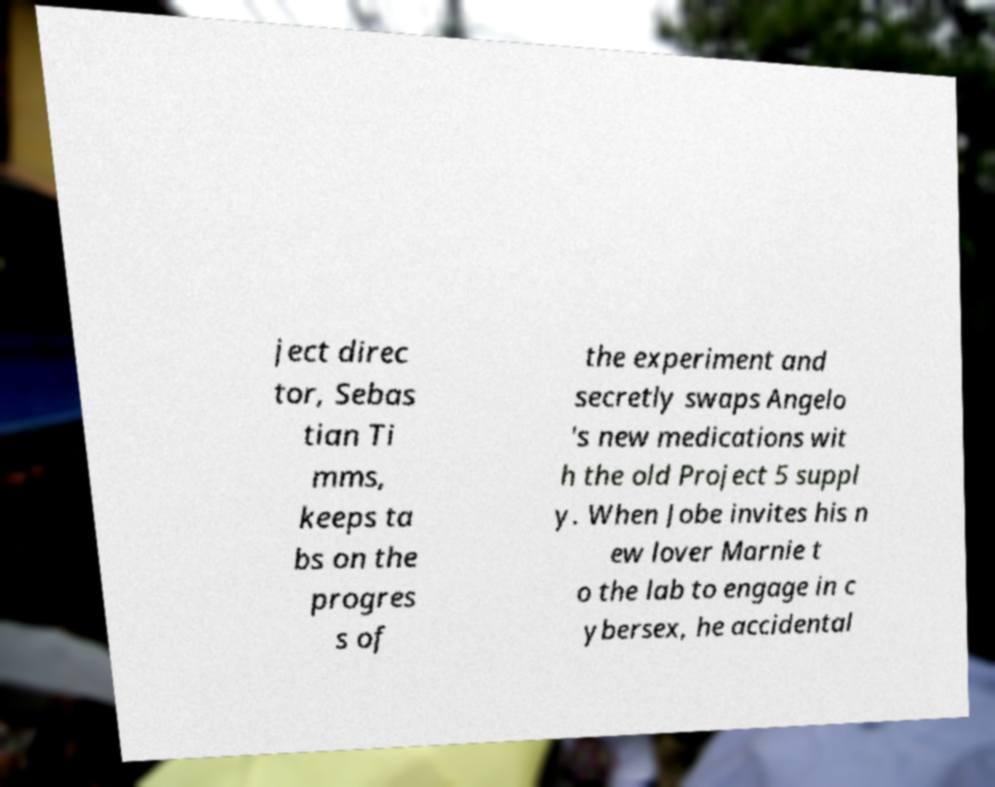Please read and relay the text visible in this image. What does it say? ject direc tor, Sebas tian Ti mms, keeps ta bs on the progres s of the experiment and secretly swaps Angelo 's new medications wit h the old Project 5 suppl y. When Jobe invites his n ew lover Marnie t o the lab to engage in c ybersex, he accidental 